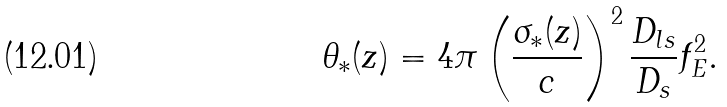<formula> <loc_0><loc_0><loc_500><loc_500>\theta _ { * } ( z ) = 4 \pi \left ( \frac { \sigma _ { * } ( z ) } { c } \right ) ^ { 2 } \frac { D _ { l s } } { D _ { s } } f _ { E } ^ { 2 } .</formula> 